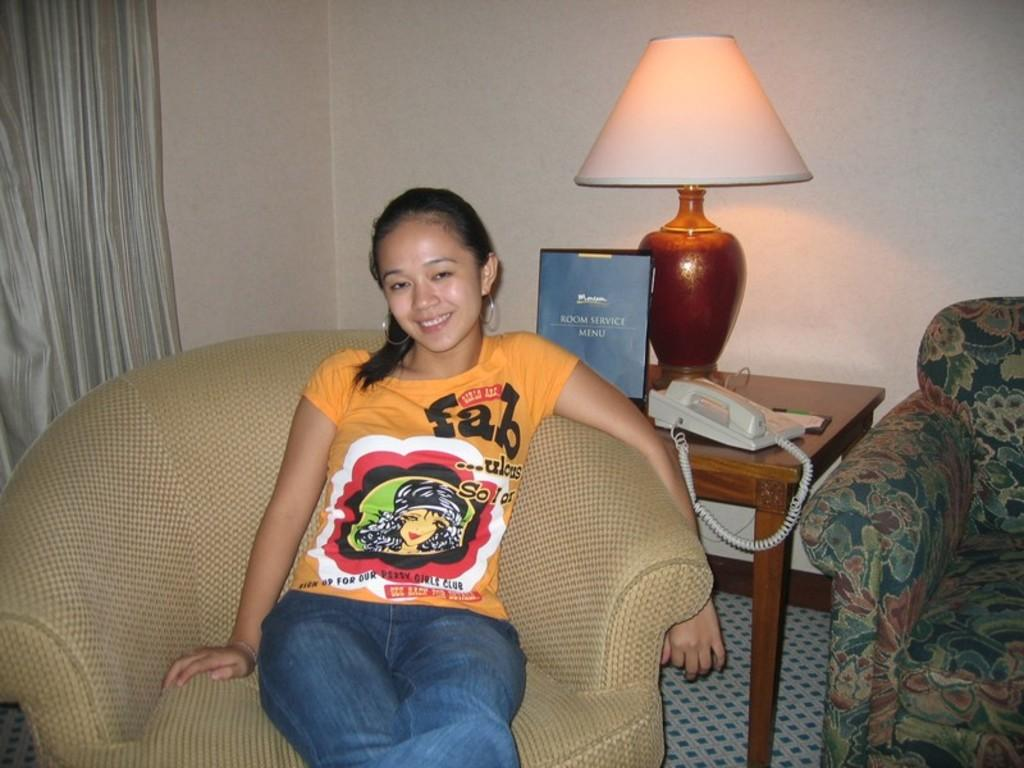What is the woman in the image doing? The woman is sitting in a chair. What can be seen in the background of the image? There is a book, a landline phone, a lamp on a table, a curtain, and a couch in the background. What type of potato is the woman holding in the image? There is no potato present in the image. What color is the sweater the woman is wearing in the image? The provided facts do not mention the woman wearing a sweater, so we cannot determine the color of a sweater in the image. 